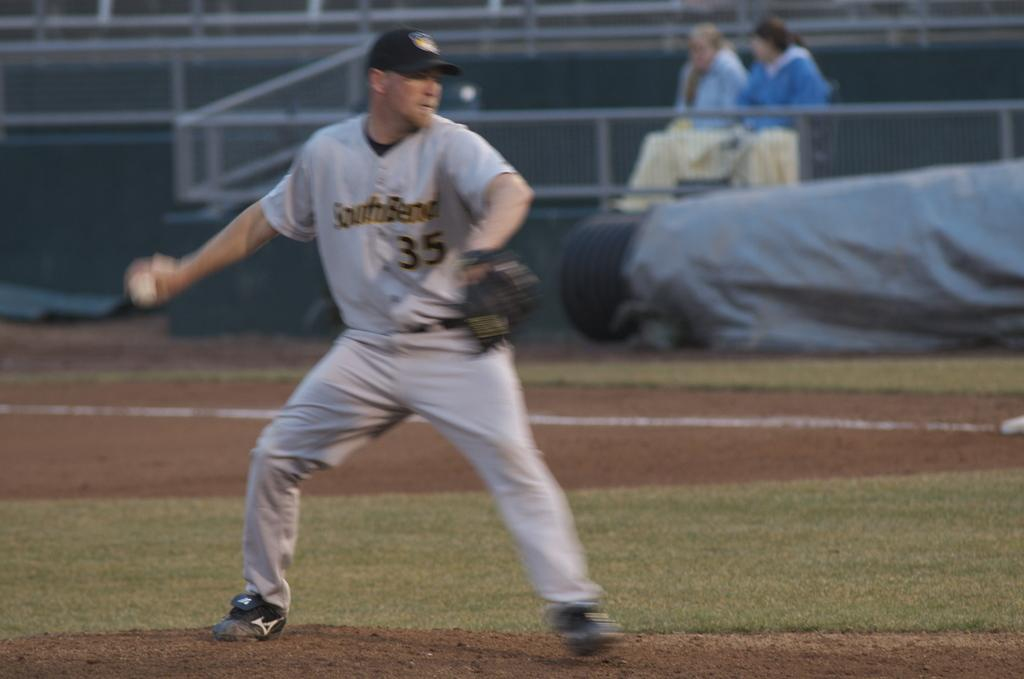<image>
Write a terse but informative summary of the picture. a baseball player with the number 35 on it 